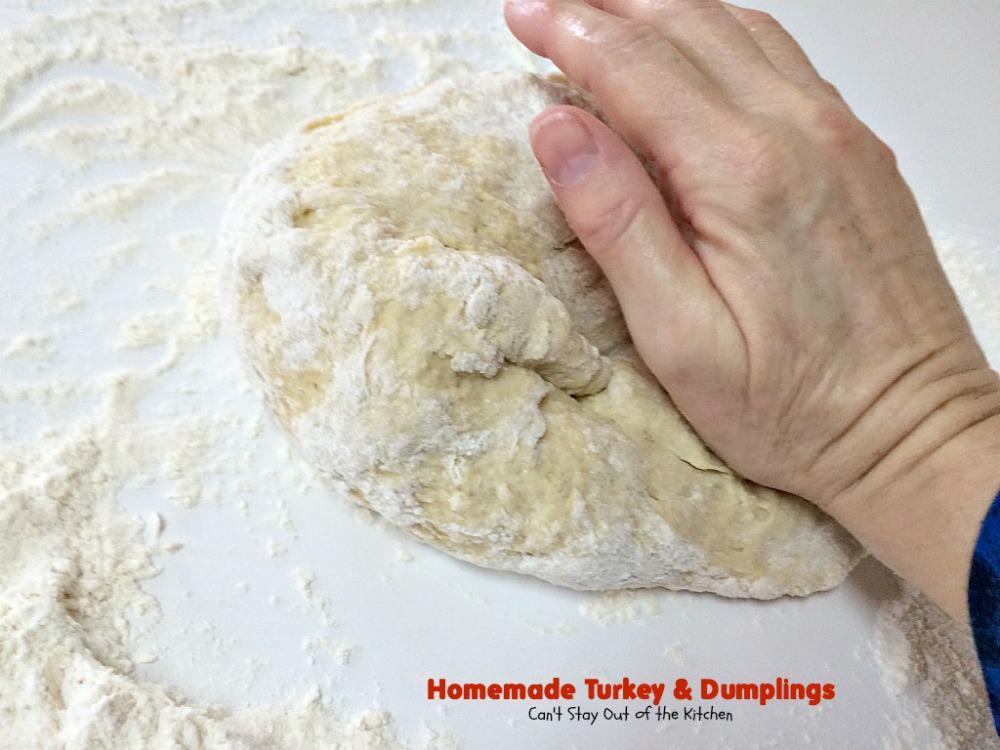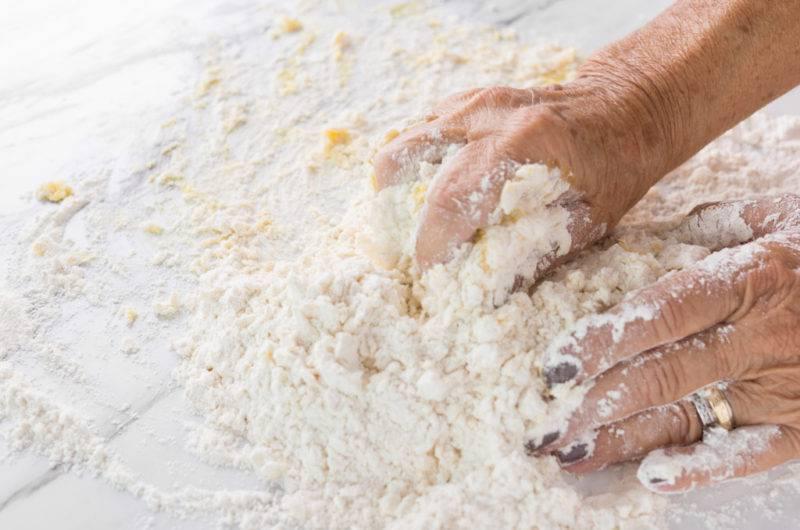The first image is the image on the left, the second image is the image on the right. Examine the images to the left and right. Is the description "Dough and flour are on a wooden cutting board." accurate? Answer yes or no. No. The first image is the image on the left, the second image is the image on the right. Analyze the images presented: Is the assertion "An image contains a human hand touching a mound of dough." valid? Answer yes or no. Yes. 